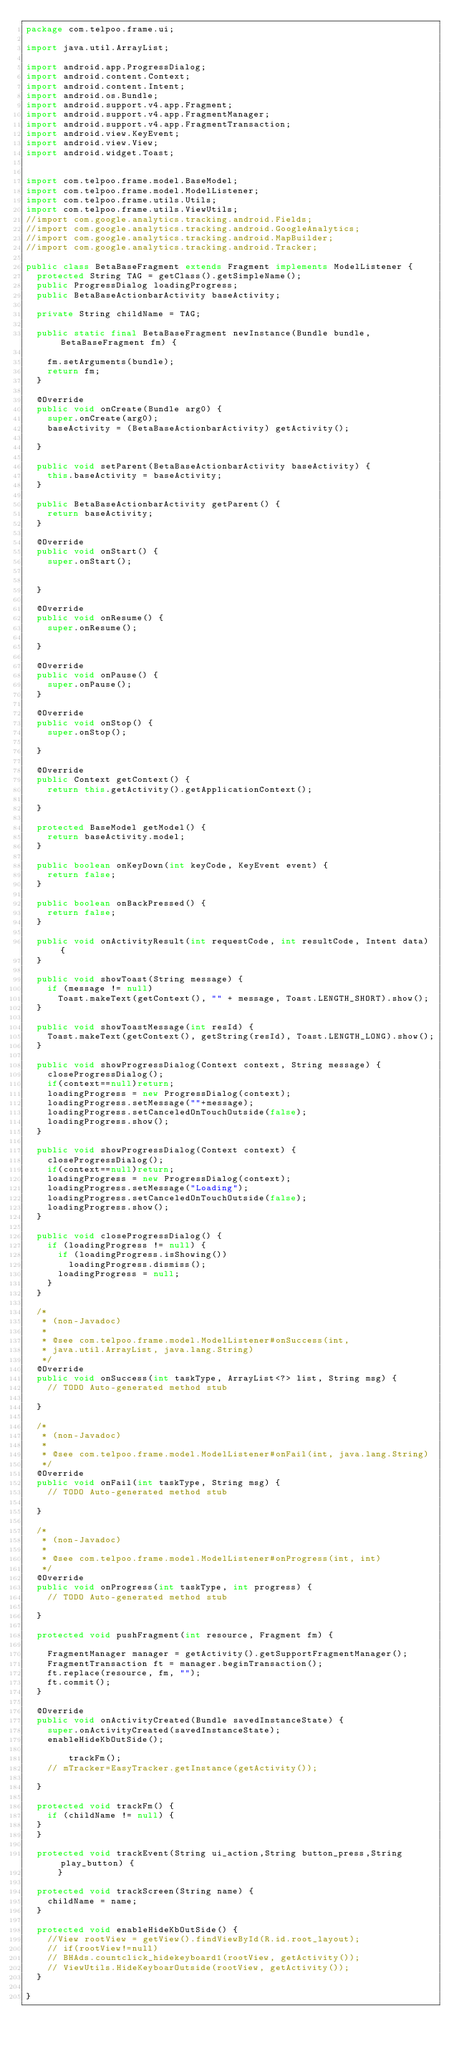Convert code to text. <code><loc_0><loc_0><loc_500><loc_500><_Java_>package com.telpoo.frame.ui;

import java.util.ArrayList;

import android.app.ProgressDialog;
import android.content.Context;
import android.content.Intent;
import android.os.Bundle;
import android.support.v4.app.Fragment;
import android.support.v4.app.FragmentManager;
import android.support.v4.app.FragmentTransaction;
import android.view.KeyEvent;
import android.view.View;
import android.widget.Toast;


import com.telpoo.frame.model.BaseModel;
import com.telpoo.frame.model.ModelListener;
import com.telpoo.frame.utils.Utils;
import com.telpoo.frame.utils.ViewUtils;
//import com.google.analytics.tracking.android.Fields;
//import com.google.analytics.tracking.android.GoogleAnalytics;
//import com.google.analytics.tracking.android.MapBuilder;
//import com.google.analytics.tracking.android.Tracker;

public class BetaBaseFragment extends Fragment implements ModelListener {
	protected String TAG = getClass().getSimpleName();
	public ProgressDialog loadingProgress;
	public BetaBaseActionbarActivity baseActivity;

	private String childName = TAG;

	public static final BetaBaseFragment newInstance(Bundle bundle, BetaBaseFragment fm) {

		fm.setArguments(bundle);
		return fm;
	}

	@Override
	public void onCreate(Bundle arg0) {
		super.onCreate(arg0);
		baseActivity = (BetaBaseActionbarActivity) getActivity();

	}

	public void setParent(BetaBaseActionbarActivity baseActivity) {
		this.baseActivity = baseActivity;
	}

	public BetaBaseActionbarActivity getParent() {
		return baseActivity;
	}

	@Override
	public void onStart() {
		super.onStart();
		

	}

	@Override
	public void onResume() {
		super.onResume();

	}

	@Override
	public void onPause() {
		super.onPause();
	}

	@Override
	public void onStop() {
		super.onStop();
	
	}

	@Override
	public Context getContext() {
		return this.getActivity().getApplicationContext();

	}

	protected BaseModel getModel() {
		return baseActivity.model;
	}

	public boolean onKeyDown(int keyCode, KeyEvent event) {
		return false;
	}

	public boolean onBackPressed() {
		return false;
	}

	public void onActivityResult(int requestCode, int resultCode, Intent data) {
	}

	public void showToast(String message) {
		if (message != null)
			Toast.makeText(getContext(), "" + message, Toast.LENGTH_SHORT).show();
	}

	public void showToastMessage(int resId) {
		Toast.makeText(getContext(), getString(resId), Toast.LENGTH_LONG).show();
	}

	public void showProgressDialog(Context context, String message) {
		closeProgressDialog();
		if(context==null)return;
		loadingProgress = new ProgressDialog(context);
		loadingProgress.setMessage(""+message);
		loadingProgress.setCanceledOnTouchOutside(false);
		loadingProgress.show();
	}

	public void showProgressDialog(Context context) {
		closeProgressDialog();
		if(context==null)return;
		loadingProgress = new ProgressDialog(context);
		loadingProgress.setMessage("Loading");
		loadingProgress.setCanceledOnTouchOutside(false);
		loadingProgress.show();
	}

	public void closeProgressDialog() {
		if (loadingProgress != null) {
			if (loadingProgress.isShowing())
				loadingProgress.dismiss();
			loadingProgress = null;
		}
	}

	/*
	 * (non-Javadoc)
	 * 
	 * @see com.telpoo.frame.model.ModelListener#onSuccess(int,
	 * java.util.ArrayList, java.lang.String)
	 */
	@Override
	public void onSuccess(int taskType, ArrayList<?> list, String msg) {
		// TODO Auto-generated method stub

	}

	/*
	 * (non-Javadoc)
	 * 
	 * @see com.telpoo.frame.model.ModelListener#onFail(int, java.lang.String)
	 */
	@Override
	public void onFail(int taskType, String msg) {
		// TODO Auto-generated method stub

	}

	/*
	 * (non-Javadoc)
	 * 
	 * @see com.telpoo.frame.model.ModelListener#onProgress(int, int)
	 */
	@Override
	public void onProgress(int taskType, int progress) {
		// TODO Auto-generated method stub

	}

	protected void pushFragment(int resource, Fragment fm) {

		FragmentManager manager = getActivity().getSupportFragmentManager();
		FragmentTransaction ft = manager.beginTransaction();
		ft.replace(resource, fm, "");
		ft.commit();
	}

	@Override
	public void onActivityCreated(Bundle savedInstanceState) {
		super.onActivityCreated(savedInstanceState);
		enableHideKbOutSide();

				trackFm();
		// mTracker=EasyTracker.getInstance(getActivity());

	}

	protected void trackFm() {
		if (childName != null) {
	}
	}

	protected void trackEvent(String ui_action,String button_press,String play_button) {
			}

	protected void trackScreen(String name) {
		childName = name;
	}

	protected void enableHideKbOutSide() {
		//View rootView = getView().findViewById(R.id.root_layout);
		// if(rootView!=null)
		// BHAds.countclick_hidekeyboard1(rootView, getActivity());
		// ViewUtils.HideKeyboarOutside(rootView, getActivity());
	}

}
</code> 